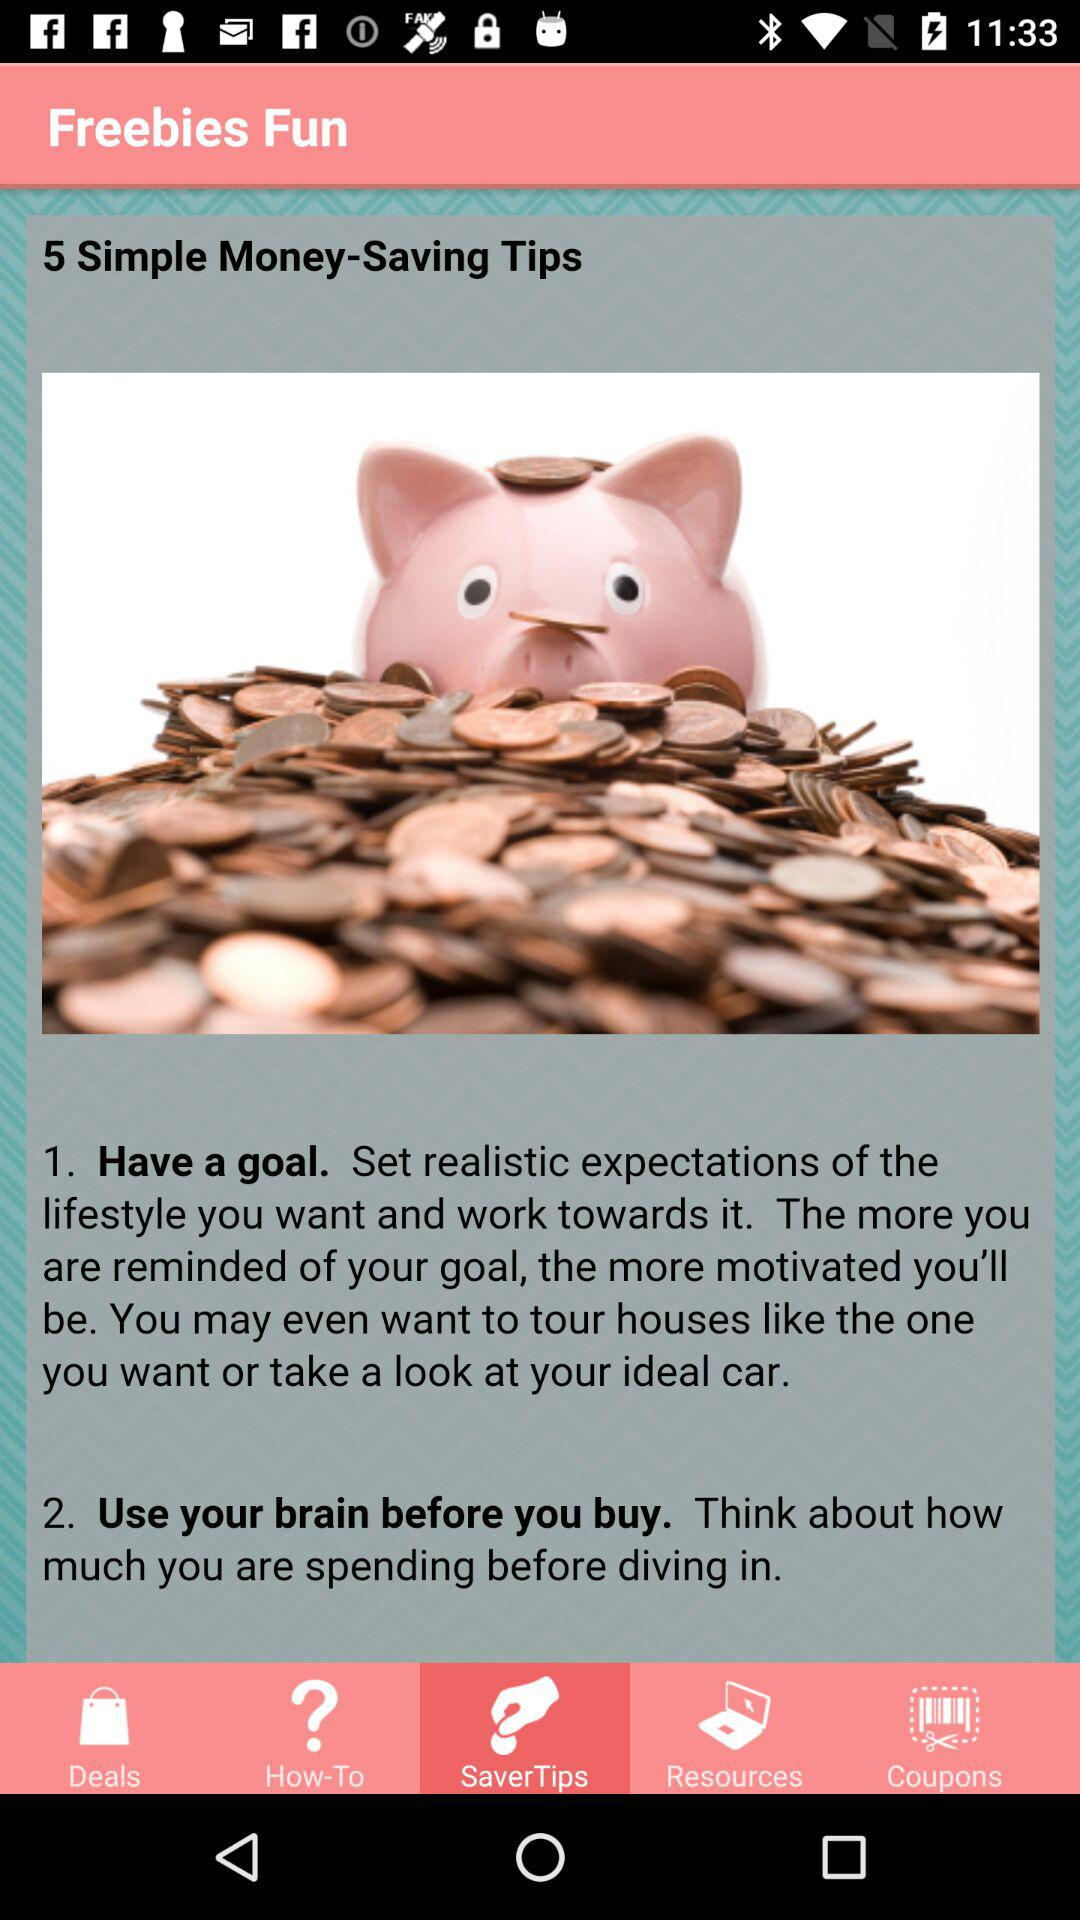How many saving tips are available? There are 5 saving tips. 